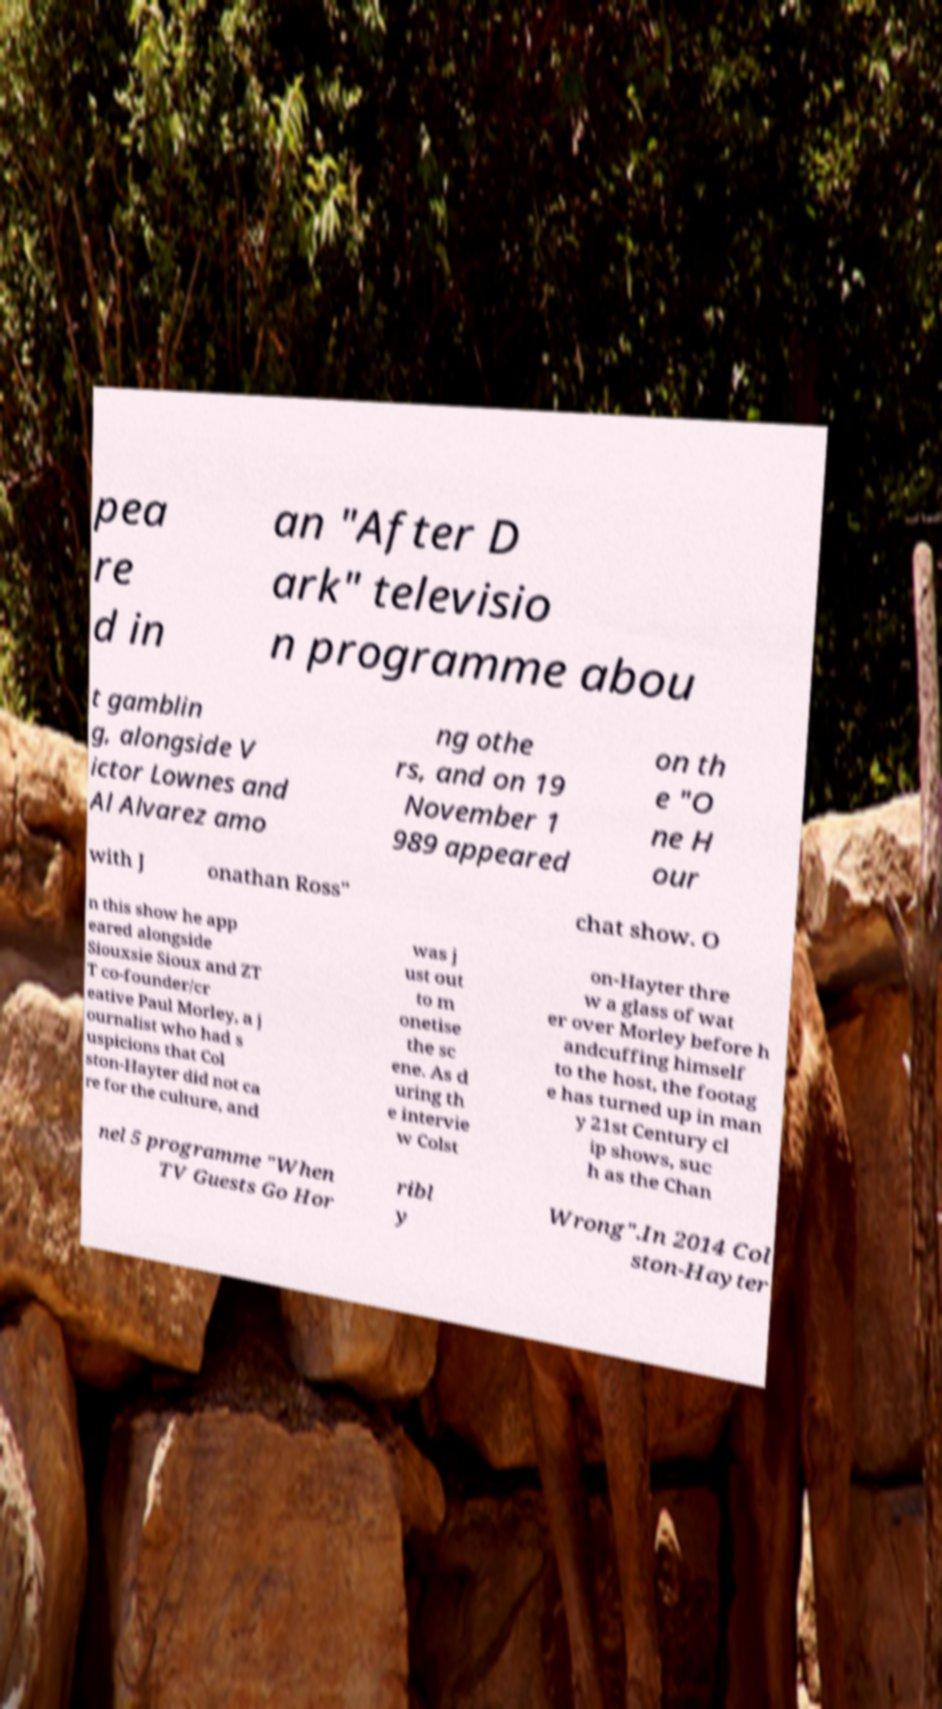There's text embedded in this image that I need extracted. Can you transcribe it verbatim? pea re d in an "After D ark" televisio n programme abou t gamblin g, alongside V ictor Lownes and Al Alvarez amo ng othe rs, and on 19 November 1 989 appeared on th e "O ne H our with J onathan Ross" chat show. O n this show he app eared alongside Siouxsie Sioux and ZT T co-founder/cr eative Paul Morley, a j ournalist who had s uspicions that Col ston-Hayter did not ca re for the culture, and was j ust out to m onetise the sc ene. As d uring th e intervie w Colst on-Hayter thre w a glass of wat er over Morley before h andcuffing himself to the host, the footag e has turned up in man y 21st Century cl ip shows, suc h as the Chan nel 5 programme "When TV Guests Go Hor ribl y Wrong".In 2014 Col ston-Hayter 